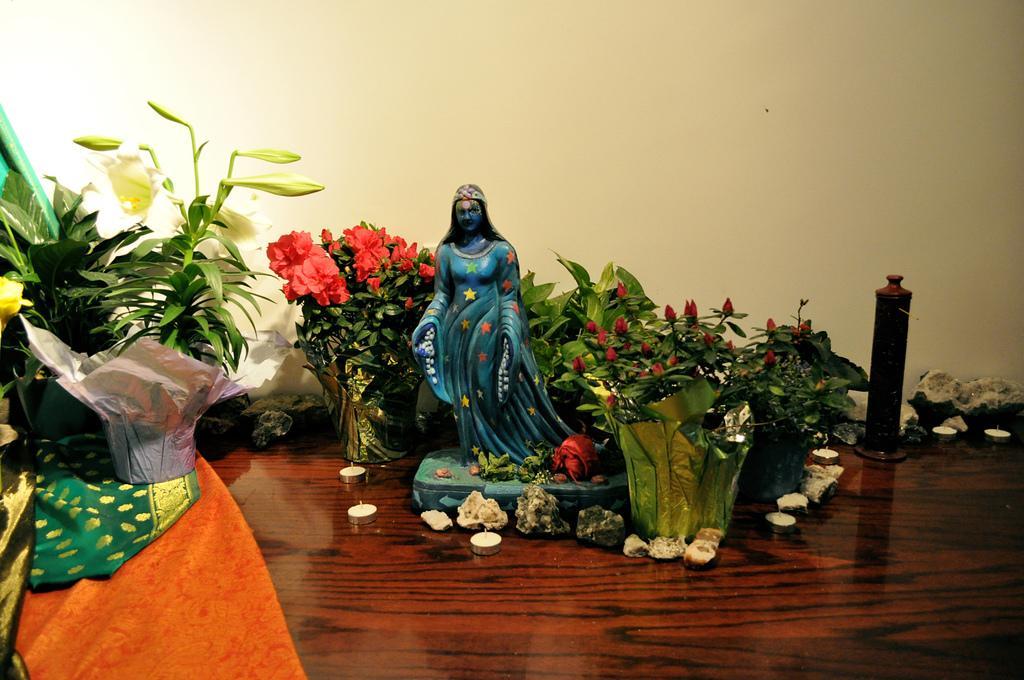Could you give a brief overview of what you see in this image? As we can see in the image there is a wall and table. On table there is a candle, plants and sculpture. 